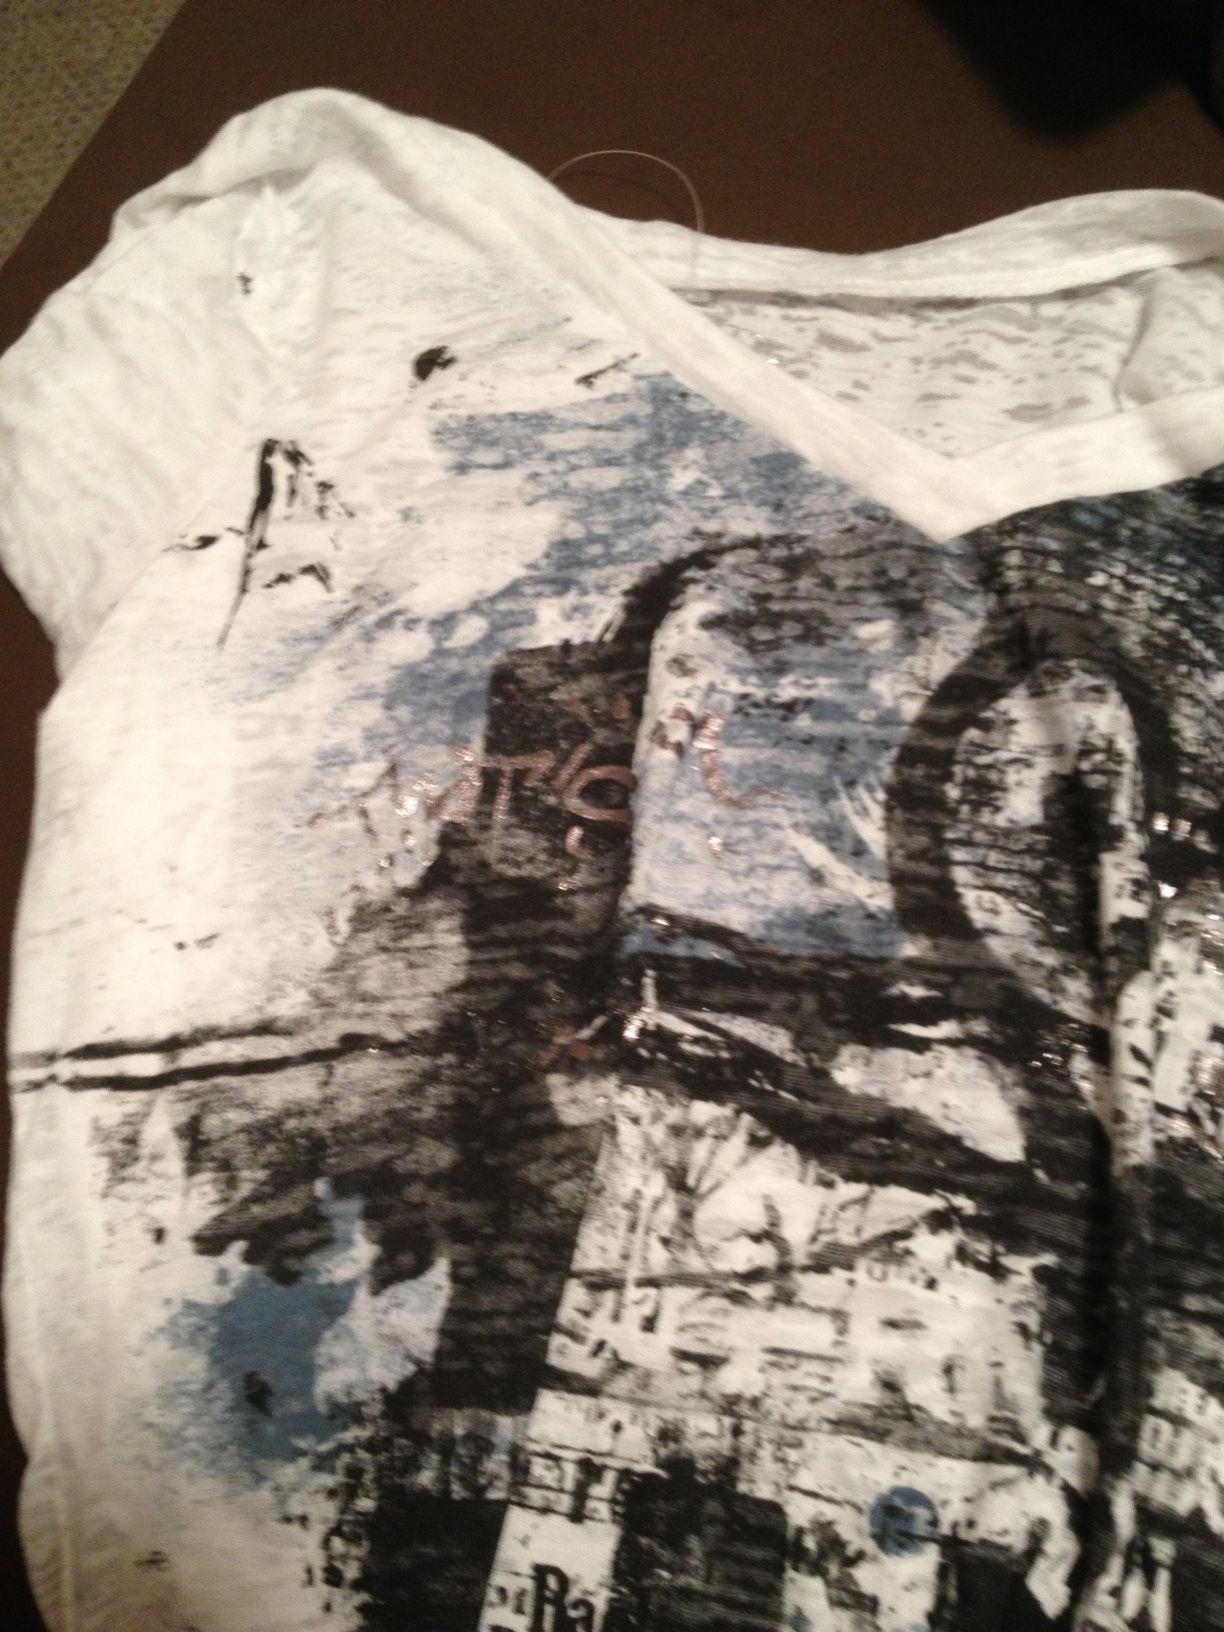What kind of design is featured on this shirt? The shirt features an abstract design with a mix of colors and patterns. There appear to be some artistic and somewhat chaotic elements that give it a unique look. It incorporates shades of black, blue, and white. 